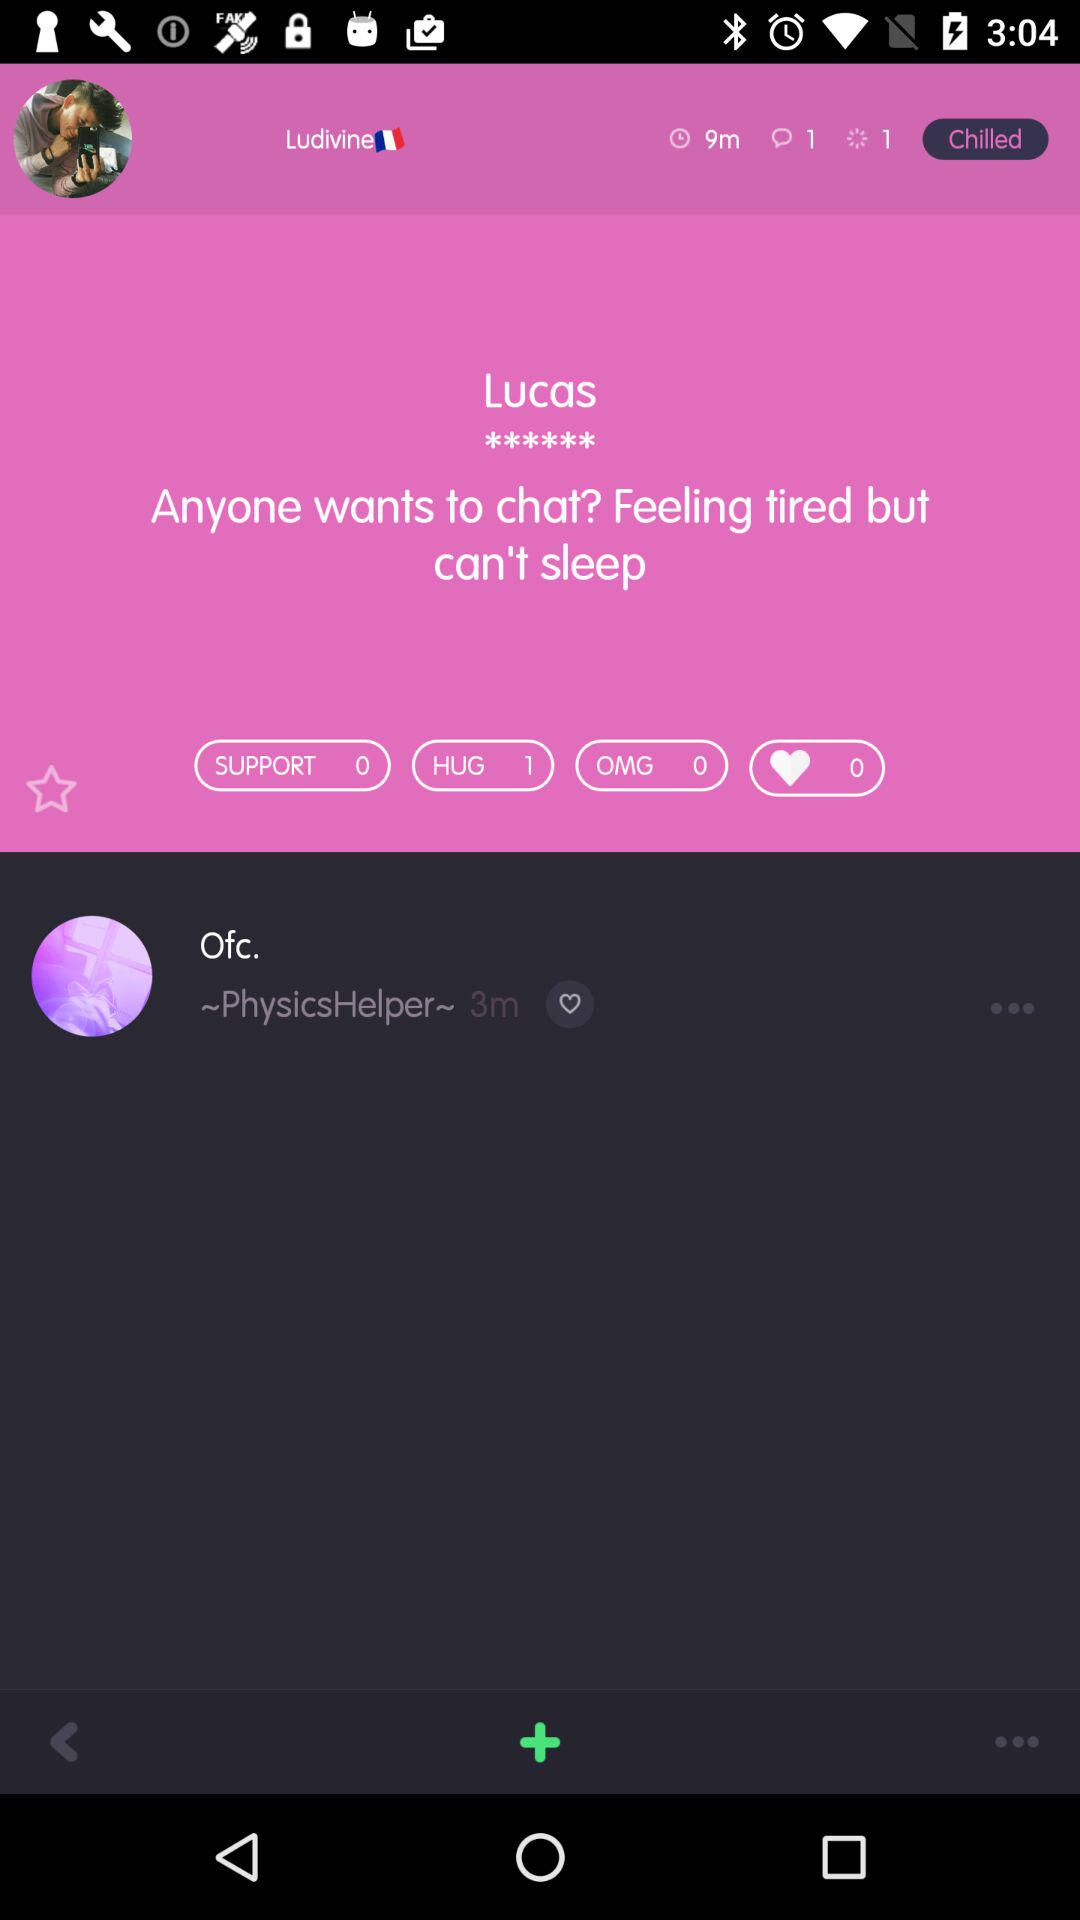How long ago was Lucas online?
When the provided information is insufficient, respond with <no answer>. <no answer> 